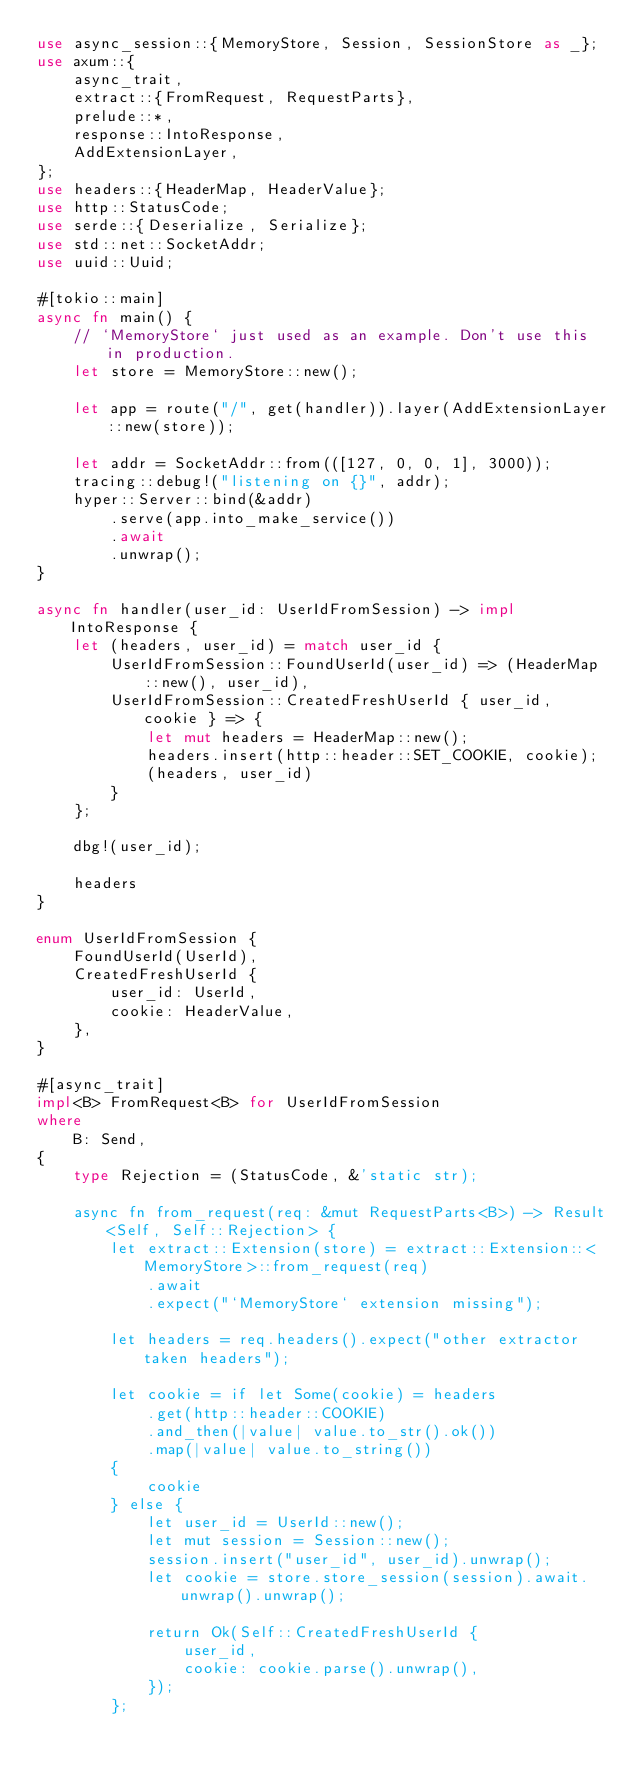<code> <loc_0><loc_0><loc_500><loc_500><_Rust_>use async_session::{MemoryStore, Session, SessionStore as _};
use axum::{
    async_trait,
    extract::{FromRequest, RequestParts},
    prelude::*,
    response::IntoResponse,
    AddExtensionLayer,
};
use headers::{HeaderMap, HeaderValue};
use http::StatusCode;
use serde::{Deserialize, Serialize};
use std::net::SocketAddr;
use uuid::Uuid;

#[tokio::main]
async fn main() {
    // `MemoryStore` just used as an example. Don't use this in production.
    let store = MemoryStore::new();

    let app = route("/", get(handler)).layer(AddExtensionLayer::new(store));

    let addr = SocketAddr::from(([127, 0, 0, 1], 3000));
    tracing::debug!("listening on {}", addr);
    hyper::Server::bind(&addr)
        .serve(app.into_make_service())
        .await
        .unwrap();
}

async fn handler(user_id: UserIdFromSession) -> impl IntoResponse {
    let (headers, user_id) = match user_id {
        UserIdFromSession::FoundUserId(user_id) => (HeaderMap::new(), user_id),
        UserIdFromSession::CreatedFreshUserId { user_id, cookie } => {
            let mut headers = HeaderMap::new();
            headers.insert(http::header::SET_COOKIE, cookie);
            (headers, user_id)
        }
    };

    dbg!(user_id);

    headers
}

enum UserIdFromSession {
    FoundUserId(UserId),
    CreatedFreshUserId {
        user_id: UserId,
        cookie: HeaderValue,
    },
}

#[async_trait]
impl<B> FromRequest<B> for UserIdFromSession
where
    B: Send,
{
    type Rejection = (StatusCode, &'static str);

    async fn from_request(req: &mut RequestParts<B>) -> Result<Self, Self::Rejection> {
        let extract::Extension(store) = extract::Extension::<MemoryStore>::from_request(req)
            .await
            .expect("`MemoryStore` extension missing");

        let headers = req.headers().expect("other extractor taken headers");

        let cookie = if let Some(cookie) = headers
            .get(http::header::COOKIE)
            .and_then(|value| value.to_str().ok())
            .map(|value| value.to_string())
        {
            cookie
        } else {
            let user_id = UserId::new();
            let mut session = Session::new();
            session.insert("user_id", user_id).unwrap();
            let cookie = store.store_session(session).await.unwrap().unwrap();

            return Ok(Self::CreatedFreshUserId {
                user_id,
                cookie: cookie.parse().unwrap(),
            });
        };
</code> 